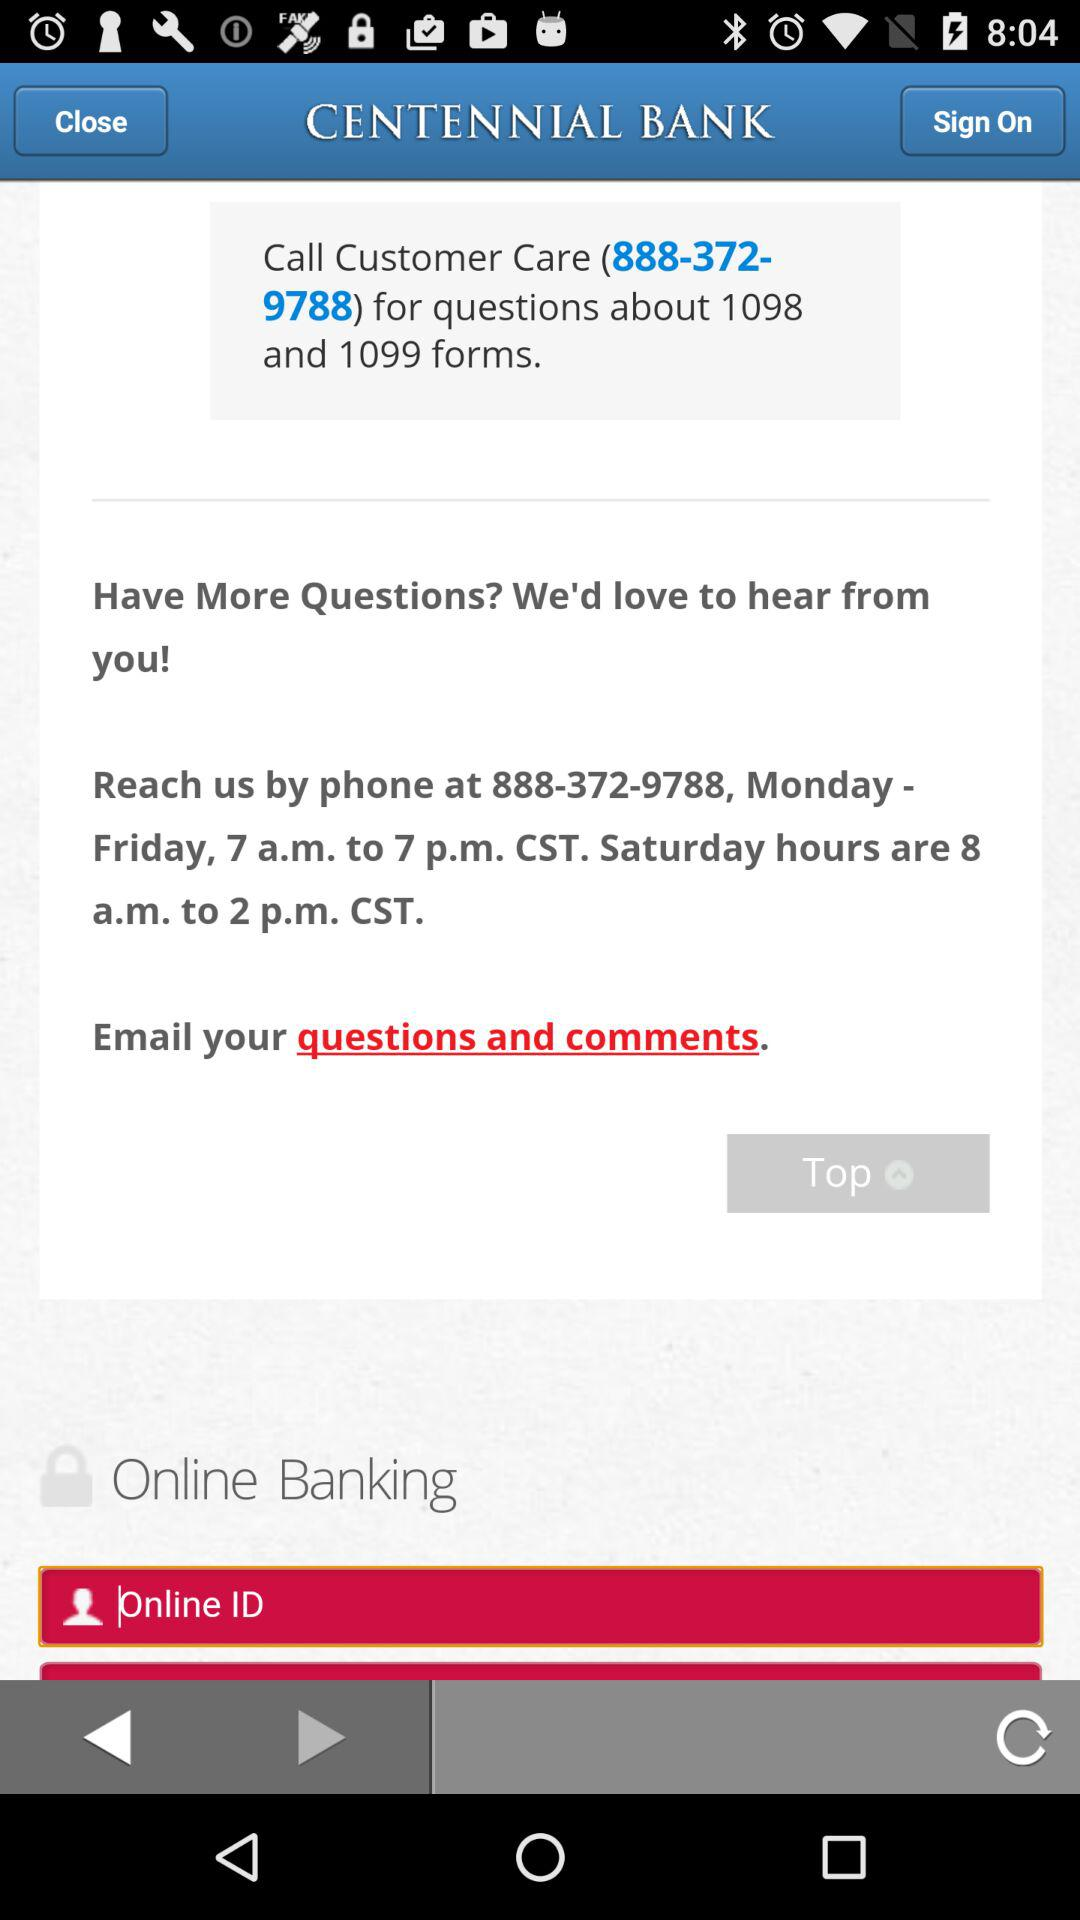What is the application name? The application name is "CENTENNIAL BANK". 